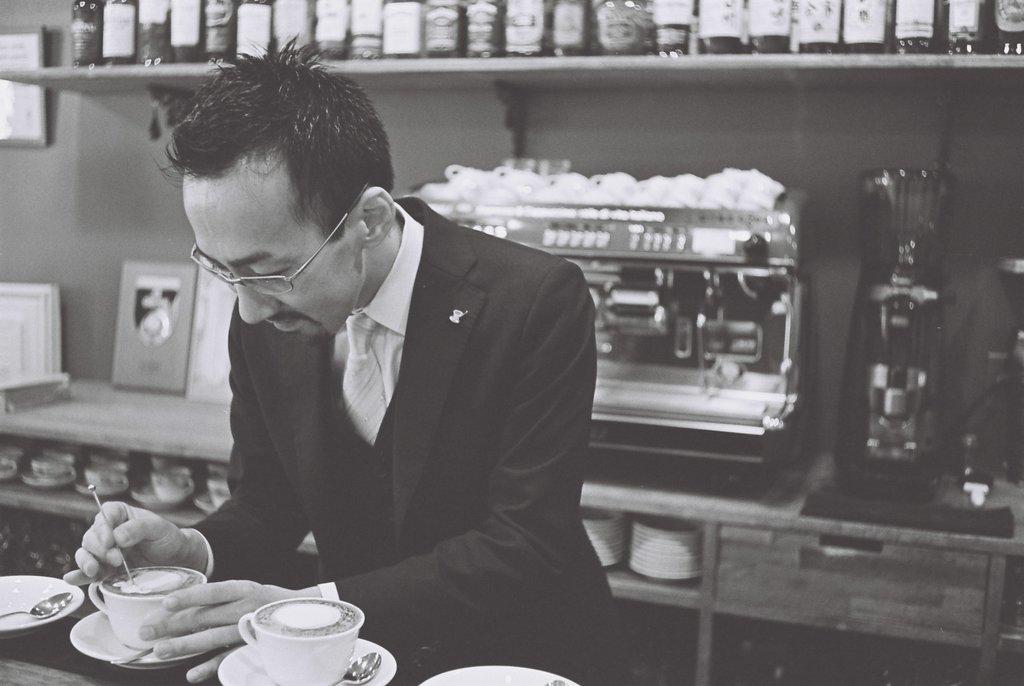In one or two sentences, can you explain what this image depicts? In this image there is a person wearing a black blazer and tie and he was making a coffee art. In the background there are group of bottles, coffee machine, saucers and cups and cupboards. 